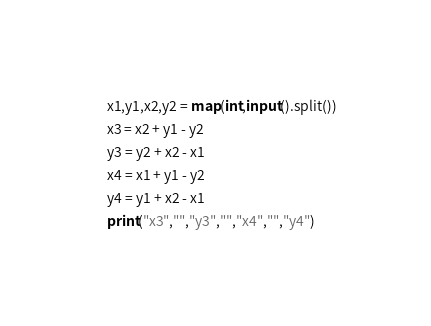Convert code to text. <code><loc_0><loc_0><loc_500><loc_500><_Python_>x1,y1,x2,y2 = map(int,input().split())
x3 = x2 + y1 - y2
y3 = y2 + x2 - x1
x4 = x1 + y1 - y2
y4 = y1 + x2 - x1
print("x3","","y3","","x4","","y4")</code> 